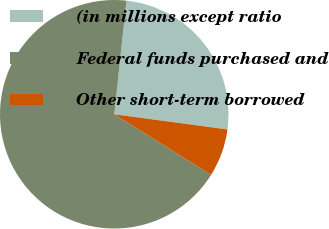Convert chart. <chart><loc_0><loc_0><loc_500><loc_500><pie_chart><fcel>(in millions except ratio<fcel>Federal funds purchased and<fcel>Other short-term borrowed<nl><fcel>25.42%<fcel>67.8%<fcel>6.78%<nl></chart> 